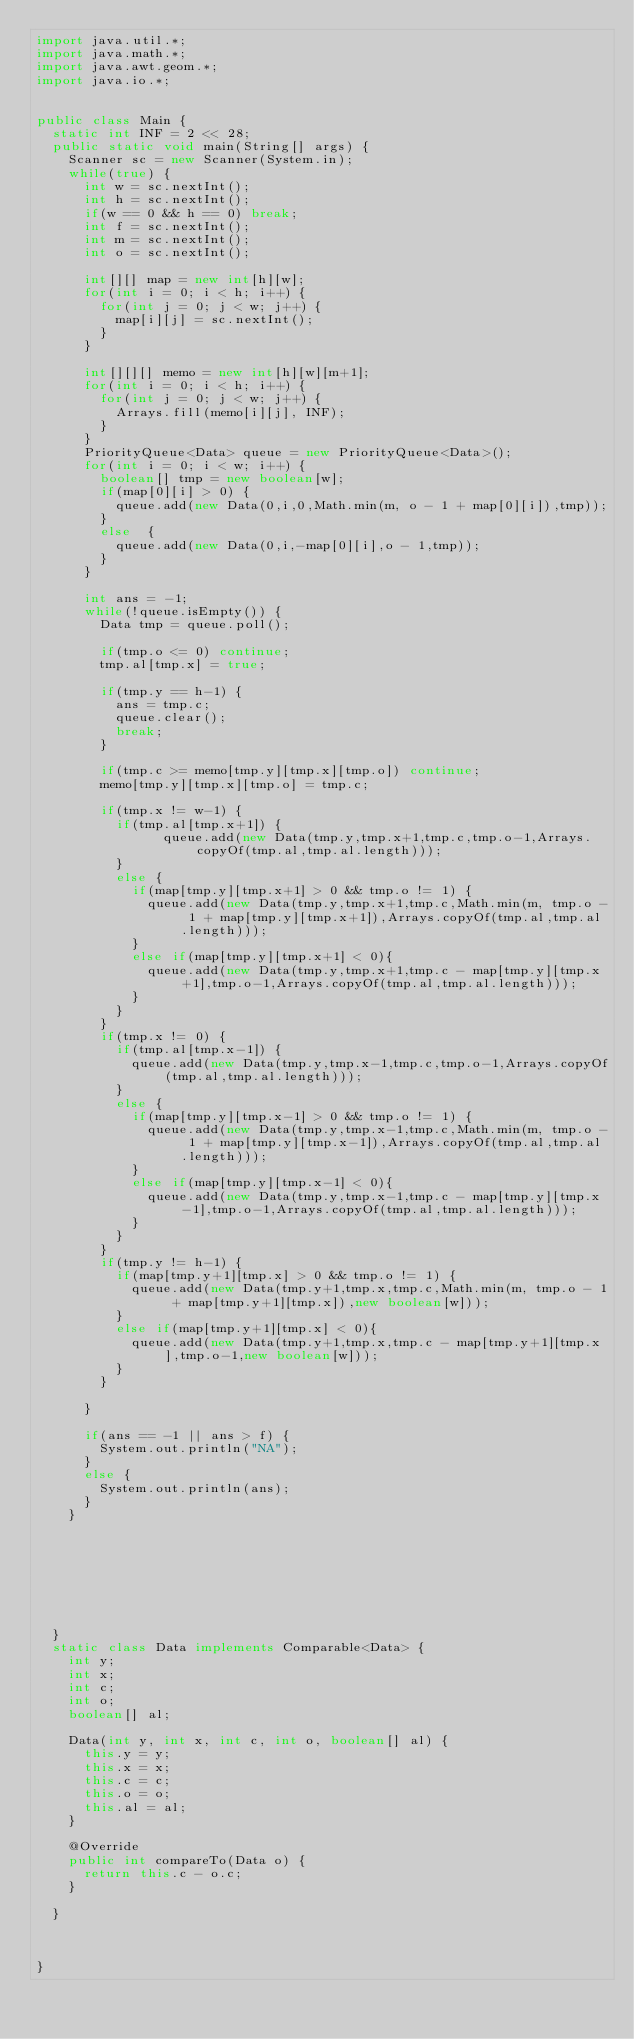<code> <loc_0><loc_0><loc_500><loc_500><_Java_>import java.util.*;
import java.math.*;
import java.awt.geom.*;
import java.io.*;
   
   
public class Main {
	static int INF = 2 << 28;
	public static void main(String[] args) {
		Scanner sc = new Scanner(System.in);
		while(true) {
			int w = sc.nextInt();
			int h = sc.nextInt();
			if(w == 0 && h == 0) break;
			int f = sc.nextInt();
			int m = sc.nextInt();
			int o = sc.nextInt();
			
			int[][] map = new int[h][w];
			for(int i = 0; i < h; i++) {
				for(int j = 0; j < w; j++) {
					map[i][j] = sc.nextInt();
				}
			}
			
			int[][][] memo = new int[h][w][m+1];
			for(int i = 0; i < h; i++) {
				for(int j = 0; j < w; j++) {
					Arrays.fill(memo[i][j], INF);
				}
			}
			PriorityQueue<Data> queue = new PriorityQueue<Data>();
			for(int i = 0; i < w; i++) {
				boolean[] tmp = new boolean[w];
				if(map[0][i] > 0) {
					queue.add(new Data(0,i,0,Math.min(m, o - 1 + map[0][i]),tmp));
				}
				else  {
					queue.add(new Data(0,i,-map[0][i],o - 1,tmp));
				}
			}
			
			int ans = -1;
			while(!queue.isEmpty()) {
				Data tmp = queue.poll();
				
				if(tmp.o <= 0) continue;
				tmp.al[tmp.x] = true;
				
				if(tmp.y == h-1) {
					ans = tmp.c;
					queue.clear();
					break;
				}
				
				if(tmp.c >= memo[tmp.y][tmp.x][tmp.o]) continue;
				memo[tmp.y][tmp.x][tmp.o] = tmp.c;
				
				if(tmp.x != w-1) {
					if(tmp.al[tmp.x+1]) {
						    queue.add(new Data(tmp.y,tmp.x+1,tmp.c,tmp.o-1,Arrays.copyOf(tmp.al,tmp.al.length)));
					}
					else {
						if(map[tmp.y][tmp.x+1] > 0 && tmp.o != 1) {
							queue.add(new Data(tmp.y,tmp.x+1,tmp.c,Math.min(m, tmp.o - 1 + map[tmp.y][tmp.x+1]),Arrays.copyOf(tmp.al,tmp.al.length)));
						}
						else if(map[tmp.y][tmp.x+1] < 0){
							queue.add(new Data(tmp.y,tmp.x+1,tmp.c - map[tmp.y][tmp.x+1],tmp.o-1,Arrays.copyOf(tmp.al,tmp.al.length)));
						}
					}
				}
				if(tmp.x != 0) {
					if(tmp.al[tmp.x-1]) {
						queue.add(new Data(tmp.y,tmp.x-1,tmp.c,tmp.o-1,Arrays.copyOf(tmp.al,tmp.al.length)));
					}
					else {
						if(map[tmp.y][tmp.x-1] > 0 && tmp.o != 1) {
							queue.add(new Data(tmp.y,tmp.x-1,tmp.c,Math.min(m, tmp.o - 1 + map[tmp.y][tmp.x-1]),Arrays.copyOf(tmp.al,tmp.al.length)));
						}
						else if(map[tmp.y][tmp.x-1] < 0){
							queue.add(new Data(tmp.y,tmp.x-1,tmp.c - map[tmp.y][tmp.x-1],tmp.o-1,Arrays.copyOf(tmp.al,tmp.al.length)));
						}
					}
				}
				if(tmp.y != h-1) {
					if(map[tmp.y+1][tmp.x] > 0 && tmp.o != 1) {
						queue.add(new Data(tmp.y+1,tmp.x,tmp.c,Math.min(m, tmp.o - 1 + map[tmp.y+1][tmp.x]),new boolean[w]));
					}
					else if(map[tmp.y+1][tmp.x] < 0){
						queue.add(new Data(tmp.y+1,tmp.x,tmp.c - map[tmp.y+1][tmp.x],tmp.o-1,new boolean[w]));
					}
				}
				
			}
			
			if(ans == -1 || ans > f) {
				System.out.println("NA");
			}
			else {
				System.out.println(ans);
			}
		}
		
		
		
		
		
		
		
		
	}
	static class Data implements Comparable<Data> {
		int y;
		int x;
		int c;
		int o;
		boolean[] al;
		
		Data(int y, int x, int c, int o, boolean[] al) {
			this.y = y;
			this.x = x;
			this.c = c;
			this.o = o;
			this.al = al;
		}

		@Override
		public int compareTo(Data o) {
			return this.c - o.c;
		}
		
	}
	
	
	
}</code> 